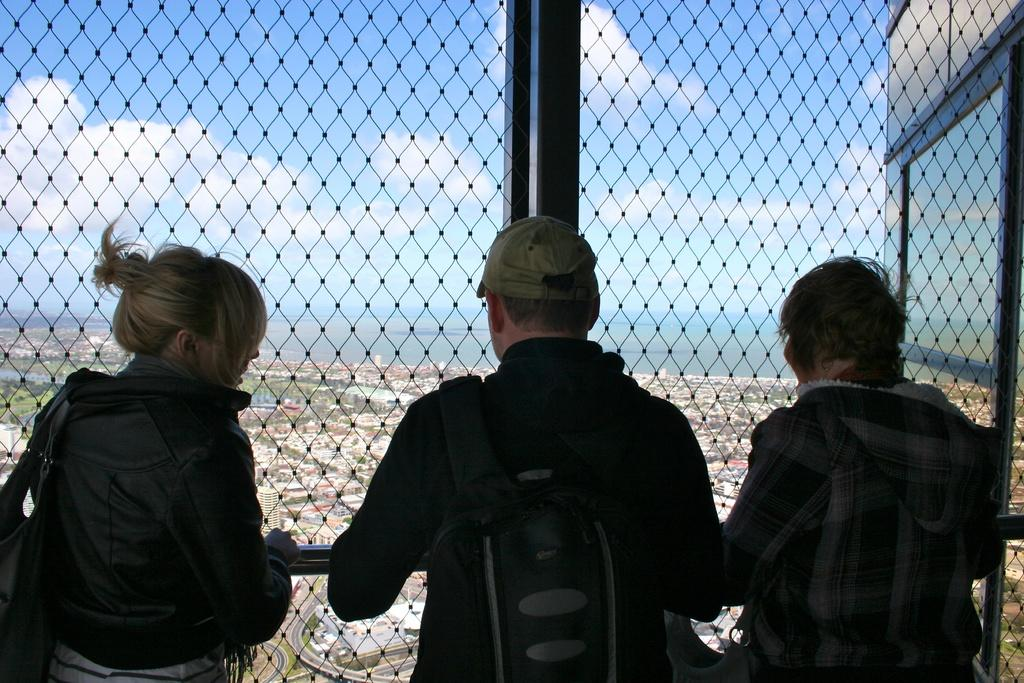How many people can be seen in the image? There are persons standing in the image. What is the fence used for in the image? The fence is used to separate the area where the persons are standing from the other elements visible through it. What can be seen through the fence? A window, buildings, water, trees, grass, a road, and the sky are visible through the fence. What is the condition of the sky in the image? The sky is visible through the fence and appears to be cloudy. What type of toys are the persons playing with in the image? There are no toys visible in the image; the persons are standing near a fence. What is the mother's role in the image? There is no mention of a mother in the image or the provided facts. 